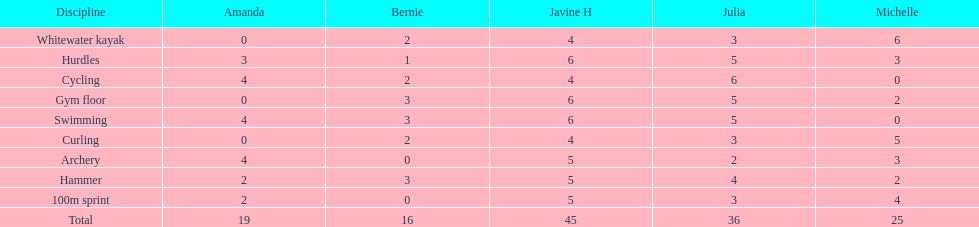Who has the greatest sum of points? Javine H. 